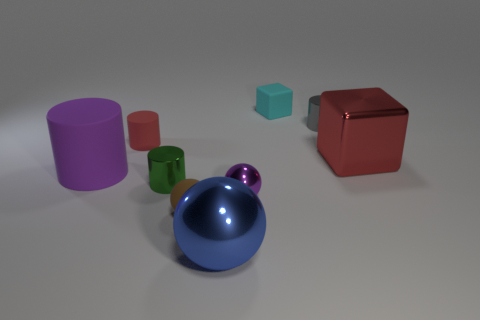What is the arrangement of the objects in terms of their proximity to each other? The objects are arranged with ample space around them, but the blue sphere is slightly closer to the green and purple cylinders compared to the spacing between other objects. Which object seems out of place in this arrangement? The small green cylinder might seem out of place as it's significantly smaller compared to the other objects and doesn't follow the same size scaling. 